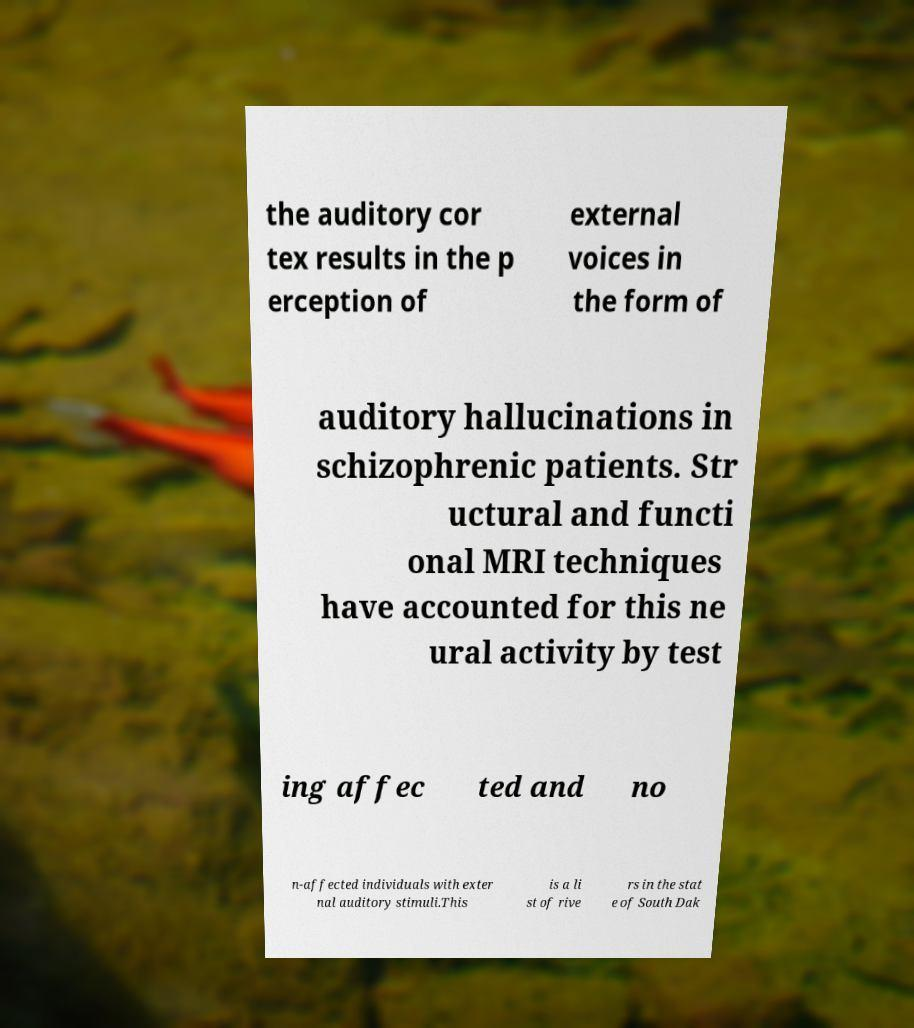Can you read and provide the text displayed in the image?This photo seems to have some interesting text. Can you extract and type it out for me? the auditory cor tex results in the p erception of external voices in the form of auditory hallucinations in schizophrenic patients. Str uctural and functi onal MRI techniques have accounted for this ne ural activity by test ing affec ted and no n-affected individuals with exter nal auditory stimuli.This is a li st of rive rs in the stat e of South Dak 